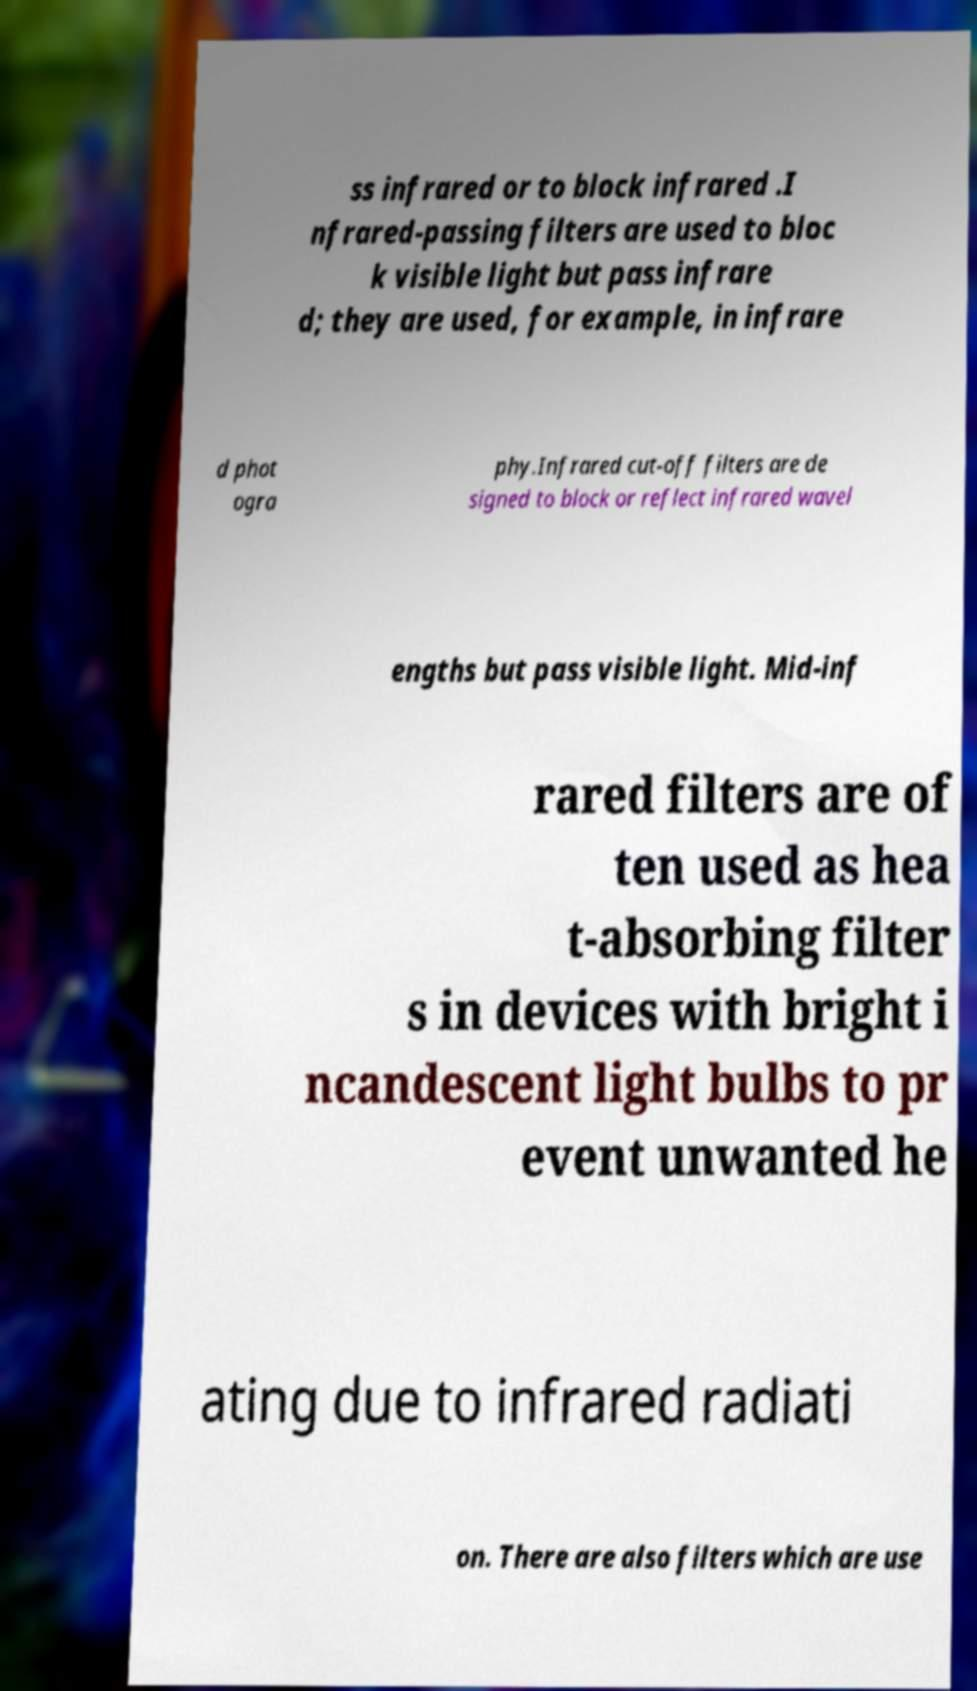Please read and relay the text visible in this image. What does it say? ss infrared or to block infrared .I nfrared-passing filters are used to bloc k visible light but pass infrare d; they are used, for example, in infrare d phot ogra phy.Infrared cut-off filters are de signed to block or reflect infrared wavel engths but pass visible light. Mid-inf rared filters are of ten used as hea t-absorbing filter s in devices with bright i ncandescent light bulbs to pr event unwanted he ating due to infrared radiati on. There are also filters which are use 